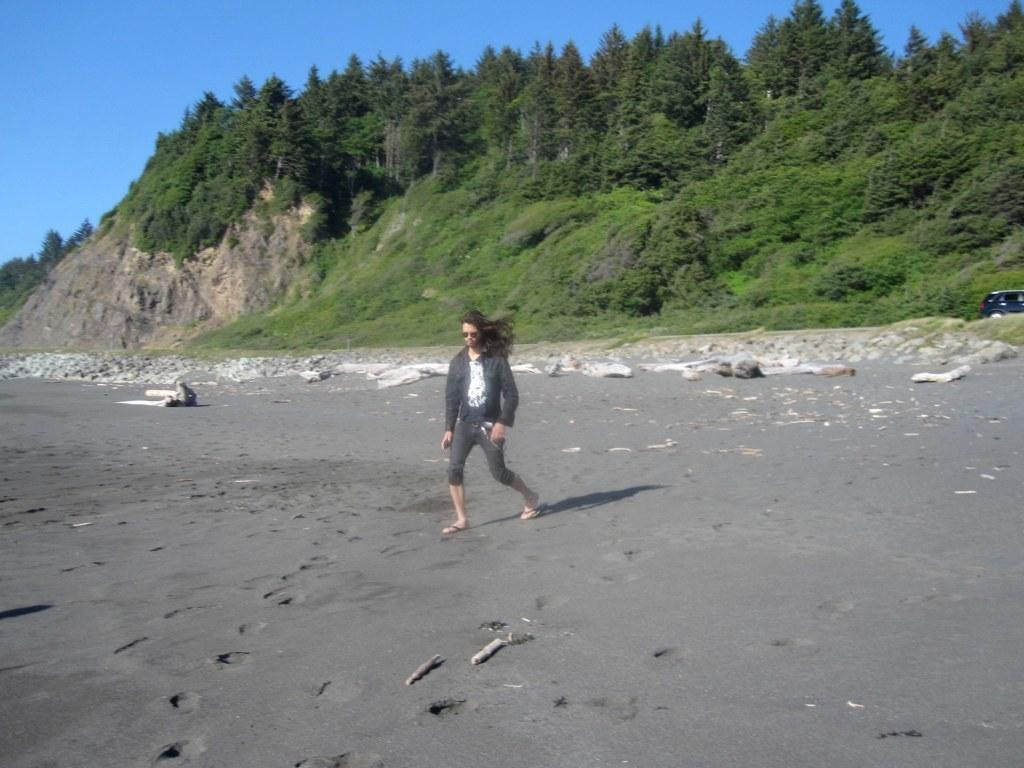What is the main subject of the image? There is a person walking in the center of the image. What can be seen in the background of the image? There are trees and a black car in the background of the image. What type of terrain is visible in the image? Grass is present on the ground in the image. What type of bead is hanging from the person's neck in the image? There is no bead visible around the person's neck in the image. What kind of plastic object can be seen on the ground near the person? There is no plastic object visible on the ground near the person in the image. 